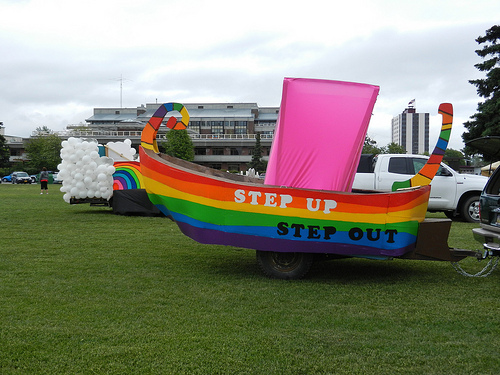<image>
Is there a white truck behind the rainbow boat? Yes. From this viewpoint, the white truck is positioned behind the rainbow boat, with the rainbow boat partially or fully occluding the white truck. Where is the white balloons in relation to the ship? Is it behind the ship? Yes. From this viewpoint, the white balloons is positioned behind the ship, with the ship partially or fully occluding the white balloons. Is the float two next to the float one? No. The float two is not positioned next to the float one. They are located in different areas of the scene. 